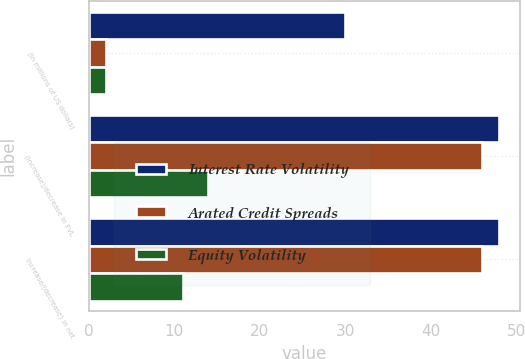<chart> <loc_0><loc_0><loc_500><loc_500><stacked_bar_chart><ecel><fcel>(in millions of US dollars)<fcel>(Increase)/decrease in FVL<fcel>Increase/(decrease) in net<nl><fcel>Interest Rate Volatility<fcel>30<fcel>48<fcel>48<nl><fcel>Arated Credit Spreads<fcel>2<fcel>46<fcel>46<nl><fcel>Equity Volatility<fcel>2<fcel>14<fcel>11<nl></chart> 